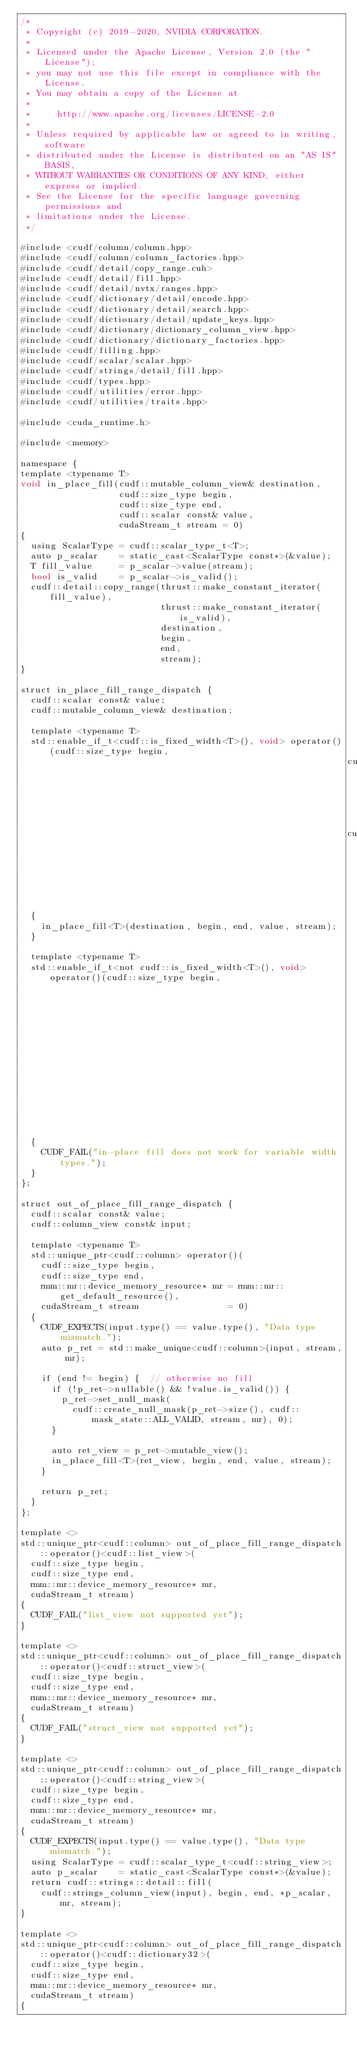Convert code to text. <code><loc_0><loc_0><loc_500><loc_500><_Cuda_>/*
 * Copyright (c) 2019-2020, NVIDIA CORPORATION.
 *
 * Licensed under the Apache License, Version 2.0 (the "License");
 * you may not use this file except in compliance with the License.
 * You may obtain a copy of the License at
 *
 *     http://www.apache.org/licenses/LICENSE-2.0
 *
 * Unless required by applicable law or agreed to in writing, software
 * distributed under the License is distributed on an "AS IS" BASIS,
 * WITHOUT WARRANTIES OR CONDITIONS OF ANY KIND, either express or implied.
 * See the License for the specific language governing permissions and
 * limitations under the License.
 */

#include <cudf/column/column.hpp>
#include <cudf/column/column_factories.hpp>
#include <cudf/detail/copy_range.cuh>
#include <cudf/detail/fill.hpp>
#include <cudf/detail/nvtx/ranges.hpp>
#include <cudf/dictionary/detail/encode.hpp>
#include <cudf/dictionary/detail/search.hpp>
#include <cudf/dictionary/detail/update_keys.hpp>
#include <cudf/dictionary/dictionary_column_view.hpp>
#include <cudf/dictionary/dictionary_factories.hpp>
#include <cudf/filling.hpp>
#include <cudf/scalar/scalar.hpp>
#include <cudf/strings/detail/fill.hpp>
#include <cudf/types.hpp>
#include <cudf/utilities/error.hpp>
#include <cudf/utilities/traits.hpp>

#include <cuda_runtime.h>

#include <memory>

namespace {
template <typename T>
void in_place_fill(cudf::mutable_column_view& destination,
                   cudf::size_type begin,
                   cudf::size_type end,
                   cudf::scalar const& value,
                   cudaStream_t stream = 0)
{
  using ScalarType = cudf::scalar_type_t<T>;
  auto p_scalar    = static_cast<ScalarType const*>(&value);
  T fill_value     = p_scalar->value(stream);
  bool is_valid    = p_scalar->is_valid();
  cudf::detail::copy_range(thrust::make_constant_iterator(fill_value),
                           thrust::make_constant_iterator(is_valid),
                           destination,
                           begin,
                           end,
                           stream);
}

struct in_place_fill_range_dispatch {
  cudf::scalar const& value;
  cudf::mutable_column_view& destination;

  template <typename T>
  std::enable_if_t<cudf::is_fixed_width<T>(), void> operator()(cudf::size_type begin,
                                                               cudf::size_type end,
                                                               cudaStream_t stream = 0)
  {
    in_place_fill<T>(destination, begin, end, value, stream);
  }

  template <typename T>
  std::enable_if_t<not cudf::is_fixed_width<T>(), void> operator()(cudf::size_type begin,
                                                                   cudf::size_type end,
                                                                   cudaStream_t stream = 0)
  {
    CUDF_FAIL("in-place fill does not work for variable width types.");
  }
};

struct out_of_place_fill_range_dispatch {
  cudf::scalar const& value;
  cudf::column_view const& input;

  template <typename T>
  std::unique_ptr<cudf::column> operator()(
    cudf::size_type begin,
    cudf::size_type end,
    rmm::mr::device_memory_resource* mr = rmm::mr::get_default_resource(),
    cudaStream_t stream                 = 0)
  {
    CUDF_EXPECTS(input.type() == value.type(), "Data type mismatch.");
    auto p_ret = std::make_unique<cudf::column>(input, stream, mr);

    if (end != begin) {  // otherwise no fill
      if (!p_ret->nullable() && !value.is_valid()) {
        p_ret->set_null_mask(
          cudf::create_null_mask(p_ret->size(), cudf::mask_state::ALL_VALID, stream, mr), 0);
      }

      auto ret_view = p_ret->mutable_view();
      in_place_fill<T>(ret_view, begin, end, value, stream);
    }

    return p_ret;
  }
};

template <>
std::unique_ptr<cudf::column> out_of_place_fill_range_dispatch::operator()<cudf::list_view>(
  cudf::size_type begin,
  cudf::size_type end,
  rmm::mr::device_memory_resource* mr,
  cudaStream_t stream)
{
  CUDF_FAIL("list_view not supported yet");
}

template <>
std::unique_ptr<cudf::column> out_of_place_fill_range_dispatch::operator()<cudf::struct_view>(
  cudf::size_type begin,
  cudf::size_type end,
  rmm::mr::device_memory_resource* mr,
  cudaStream_t stream)
{
  CUDF_FAIL("struct_view not supported yet");
}

template <>
std::unique_ptr<cudf::column> out_of_place_fill_range_dispatch::operator()<cudf::string_view>(
  cudf::size_type begin,
  cudf::size_type end,
  rmm::mr::device_memory_resource* mr,
  cudaStream_t stream)
{
  CUDF_EXPECTS(input.type() == value.type(), "Data type mismatch.");
  using ScalarType = cudf::scalar_type_t<cudf::string_view>;
  auto p_scalar    = static_cast<ScalarType const*>(&value);
  return cudf::strings::detail::fill(
    cudf::strings_column_view(input), begin, end, *p_scalar, mr, stream);
}

template <>
std::unique_ptr<cudf::column> out_of_place_fill_range_dispatch::operator()<cudf::dictionary32>(
  cudf::size_type begin,
  cudf::size_type end,
  rmm::mr::device_memory_resource* mr,
  cudaStream_t stream)
{</code> 